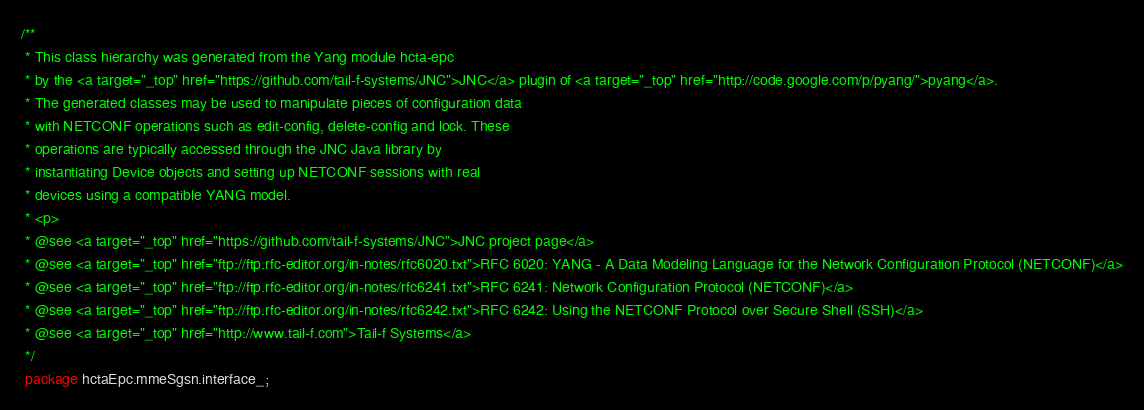<code> <loc_0><loc_0><loc_500><loc_500><_Java_>/**
 * This class hierarchy was generated from the Yang module hcta-epc
 * by the <a target="_top" href="https://github.com/tail-f-systems/JNC">JNC</a> plugin of <a target="_top" href="http://code.google.com/p/pyang/">pyang</a>.
 * The generated classes may be used to manipulate pieces of configuration data
 * with NETCONF operations such as edit-config, delete-config and lock. These
 * operations are typically accessed through the JNC Java library by
 * instantiating Device objects and setting up NETCONF sessions with real
 * devices using a compatible YANG model.
 * <p>
 * @see <a target="_top" href="https://github.com/tail-f-systems/JNC">JNC project page</a>
 * @see <a target="_top" href="ftp://ftp.rfc-editor.org/in-notes/rfc6020.txt">RFC 6020: YANG - A Data Modeling Language for the Network Configuration Protocol (NETCONF)</a>
 * @see <a target="_top" href="ftp://ftp.rfc-editor.org/in-notes/rfc6241.txt">RFC 6241: Network Configuration Protocol (NETCONF)</a>
 * @see <a target="_top" href="ftp://ftp.rfc-editor.org/in-notes/rfc6242.txt">RFC 6242: Using the NETCONF Protocol over Secure Shell (SSH)</a>
 * @see <a target="_top" href="http://www.tail-f.com">Tail-f Systems</a>
 */
 package hctaEpc.mmeSgsn.interface_;</code> 